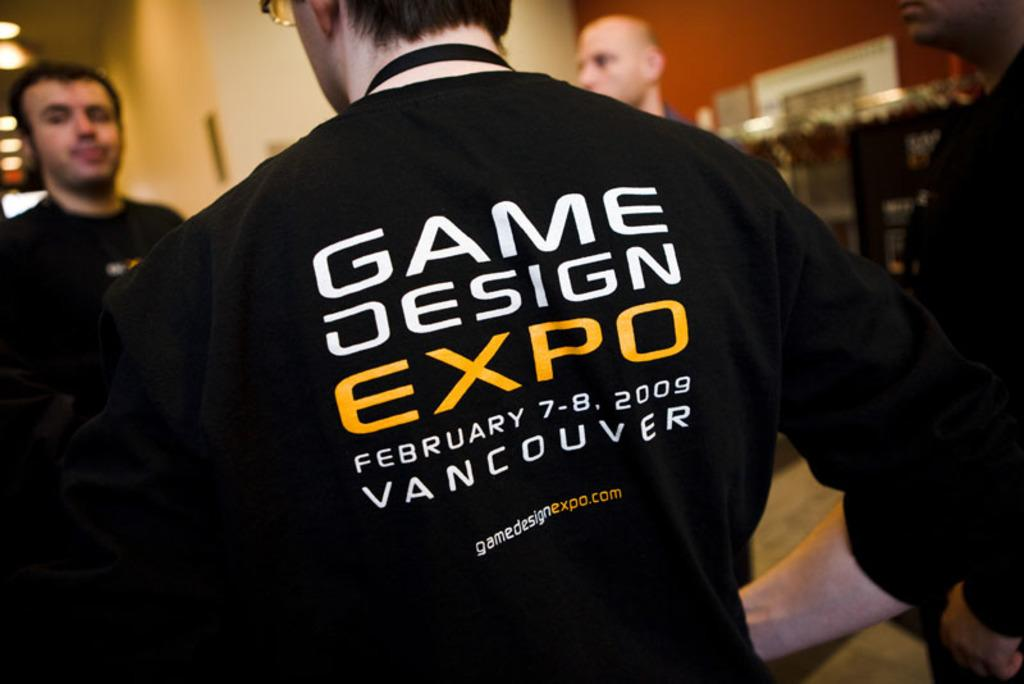<image>
Provide a brief description of the given image. The back of a black shirt promotes a Game Design Expo in Vancouver. 